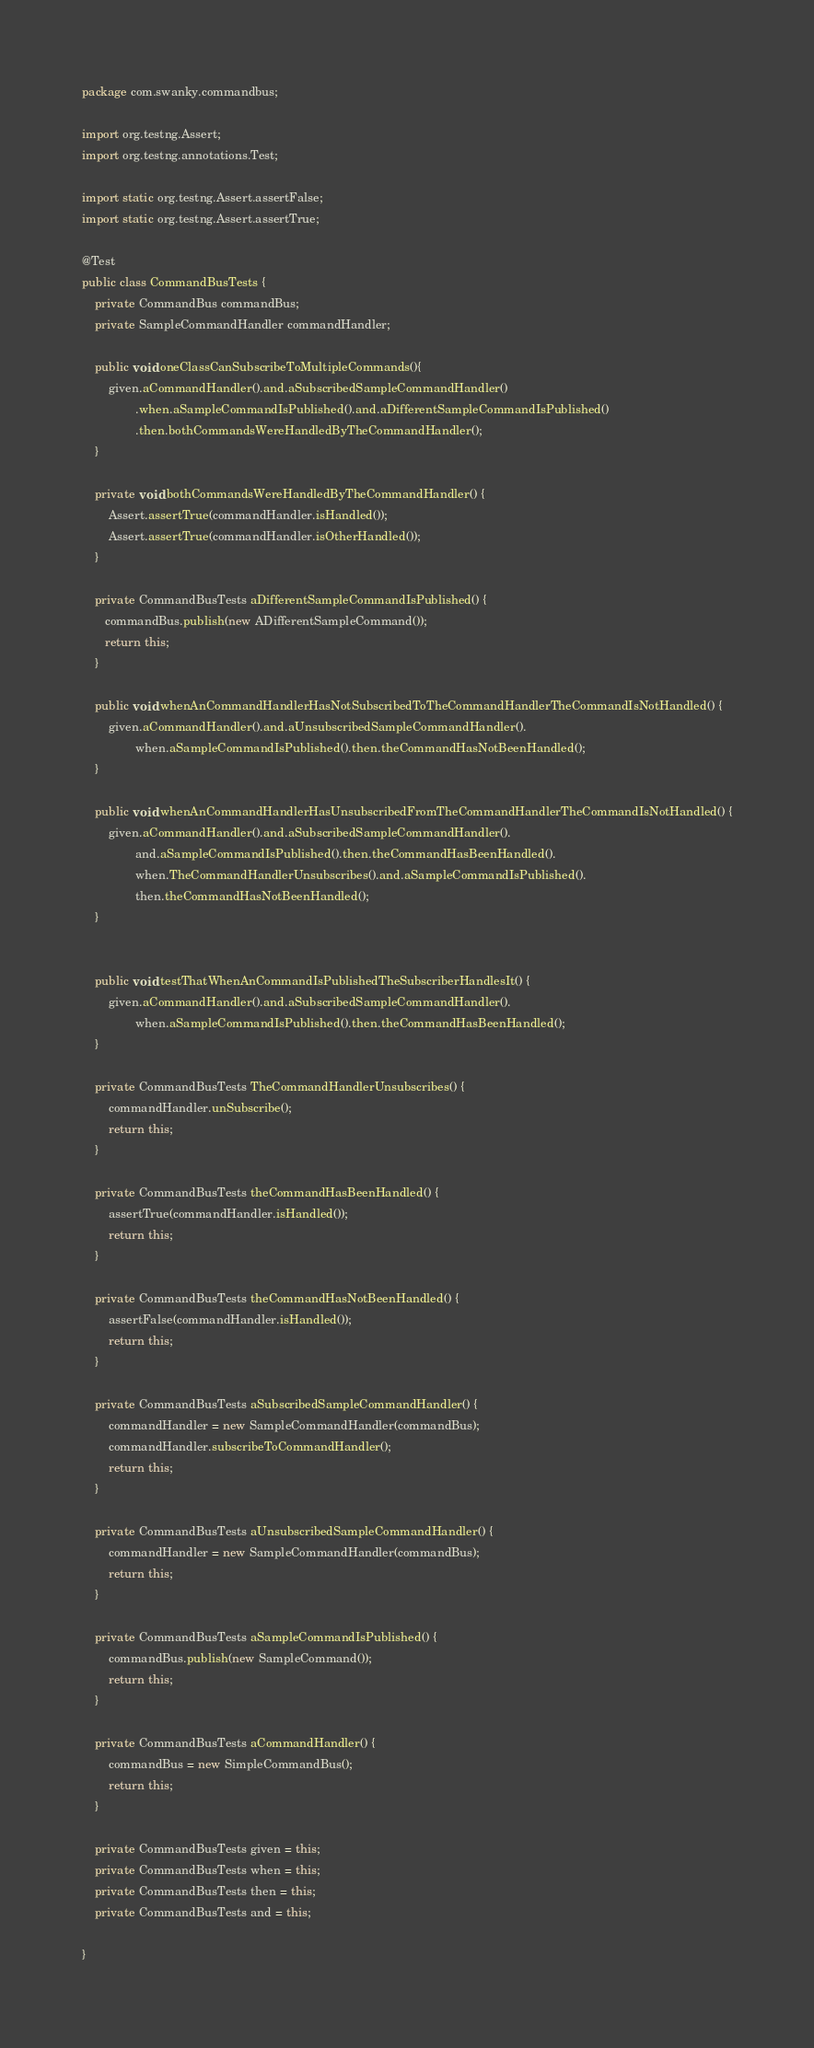<code> <loc_0><loc_0><loc_500><loc_500><_Java_>package com.swanky.commandbus;

import org.testng.Assert;
import org.testng.annotations.Test;

import static org.testng.Assert.assertFalse;
import static org.testng.Assert.assertTrue;

@Test
public class CommandBusTests {
    private CommandBus commandBus;
    private SampleCommandHandler commandHandler;

    public void oneClassCanSubscribeToMultipleCommands(){
        given.aCommandHandler().and.aSubscribedSampleCommandHandler()
                .when.aSampleCommandIsPublished().and.aDifferentSampleCommandIsPublished()
                .then.bothCommandsWereHandledByTheCommandHandler();
    }

    private void bothCommandsWereHandledByTheCommandHandler() {
        Assert.assertTrue(commandHandler.isHandled());
        Assert.assertTrue(commandHandler.isOtherHandled());
    }

    private CommandBusTests aDifferentSampleCommandIsPublished() {
       commandBus.publish(new ADifferentSampleCommand());
       return this;
    }

    public void whenAnCommandHandlerHasNotSubscribedToTheCommandHandlerTheCommandIsNotHandled() {
        given.aCommandHandler().and.aUnsubscribedSampleCommandHandler().
                when.aSampleCommandIsPublished().then.theCommandHasNotBeenHandled();
    }

    public void whenAnCommandHandlerHasUnsubscribedFromTheCommandHandlerTheCommandIsNotHandled() {
        given.aCommandHandler().and.aSubscribedSampleCommandHandler().
                and.aSampleCommandIsPublished().then.theCommandHasBeenHandled().
                when.TheCommandHandlerUnsubscribes().and.aSampleCommandIsPublished().
                then.theCommandHasNotBeenHandled();
    }


    public void testThatWhenAnCommandIsPublishedTheSubscriberHandlesIt() {
        given.aCommandHandler().and.aSubscribedSampleCommandHandler().
                when.aSampleCommandIsPublished().then.theCommandHasBeenHandled();
    }

    private CommandBusTests TheCommandHandlerUnsubscribes() {
        commandHandler.unSubscribe();
        return this;
    }

    private CommandBusTests theCommandHasBeenHandled() {
        assertTrue(commandHandler.isHandled());
        return this;
    }

    private CommandBusTests theCommandHasNotBeenHandled() {
        assertFalse(commandHandler.isHandled());
        return this;
    }

    private CommandBusTests aSubscribedSampleCommandHandler() {
        commandHandler = new SampleCommandHandler(commandBus);
        commandHandler.subscribeToCommandHandler();
        return this;
    }

    private CommandBusTests aUnsubscribedSampleCommandHandler() {
        commandHandler = new SampleCommandHandler(commandBus);
        return this;
    }

    private CommandBusTests aSampleCommandIsPublished() {
        commandBus.publish(new SampleCommand());
        return this;
    }

    private CommandBusTests aCommandHandler() {
        commandBus = new SimpleCommandBus();
        return this;
    }

    private CommandBusTests given = this;
    private CommandBusTests when = this;
    private CommandBusTests then = this;
    private CommandBusTests and = this;

}
</code> 